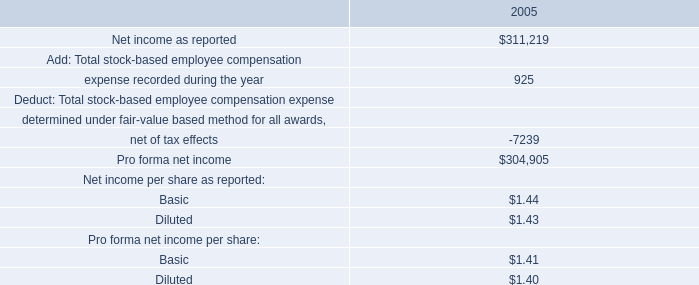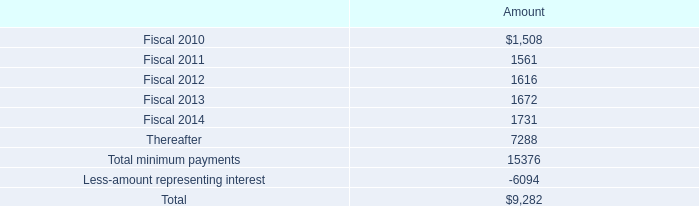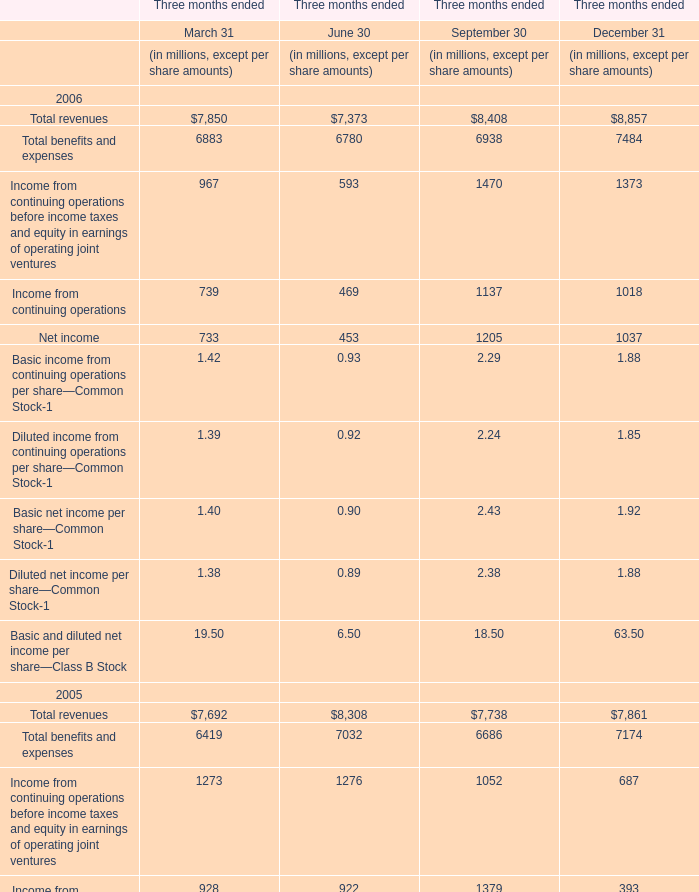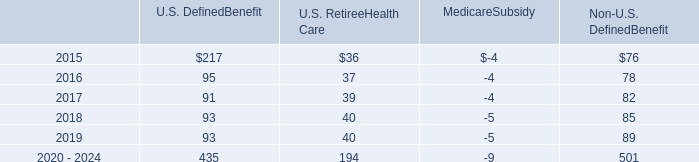What is the average amount of Fiscal 2014 of Amount, and Net income as reported of 2005 ? 
Computations: ((1731.0 + 311219.0) / 2)
Answer: 156475.0. 